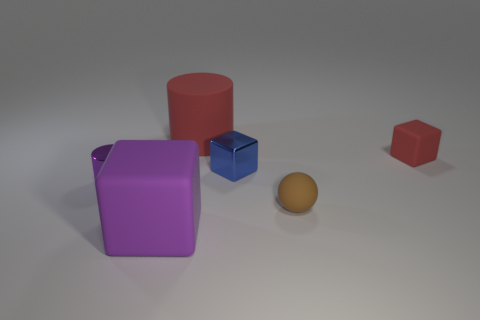Is there any other thing that has the same color as the tiny ball?
Your response must be concise. No. What is the size of the purple cube?
Your answer should be compact. Large. Do the tiny block behind the blue metal thing and the purple cylinder have the same material?
Give a very brief answer. No. Is the shape of the large red thing the same as the tiny brown object?
Your answer should be very brief. No. The large matte object that is behind the small shiny thing that is to the left of the big thing that is behind the red block is what shape?
Provide a short and direct response. Cylinder. Do the large object that is on the right side of the large purple thing and the thing that is to the left of the big rubber block have the same shape?
Give a very brief answer. Yes. Are there any cylinders made of the same material as the small blue cube?
Provide a succinct answer. Yes. The thing that is behind the tiny rubber cube behind the tiny blue metal thing to the right of the tiny purple thing is what color?
Offer a very short reply. Red. Does the cylinder that is on the right side of the purple block have the same material as the purple thing to the left of the big purple object?
Offer a terse response. No. There is a rubber object that is on the right side of the tiny brown sphere; what shape is it?
Ensure brevity in your answer.  Cube. 